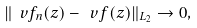Convert formula to latex. <formula><loc_0><loc_0><loc_500><loc_500>\| \ v f _ { n } ( z ) - \ v f ( z ) \| _ { L _ { 2 } } \to 0 ,</formula> 